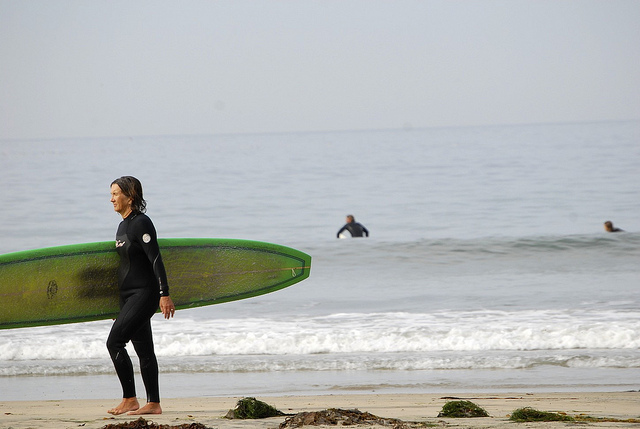How many people can you see in the image? I can see three people in the image. One person is in the foreground, walking along the shore with a surfboard, while two additional individuals can be seen further out in the ocean. 